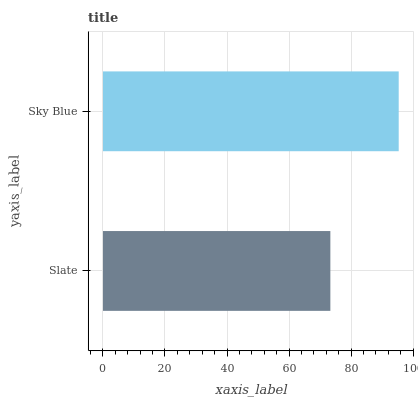Is Slate the minimum?
Answer yes or no. Yes. Is Sky Blue the maximum?
Answer yes or no. Yes. Is Sky Blue the minimum?
Answer yes or no. No. Is Sky Blue greater than Slate?
Answer yes or no. Yes. Is Slate less than Sky Blue?
Answer yes or no. Yes. Is Slate greater than Sky Blue?
Answer yes or no. No. Is Sky Blue less than Slate?
Answer yes or no. No. Is Sky Blue the high median?
Answer yes or no. Yes. Is Slate the low median?
Answer yes or no. Yes. Is Slate the high median?
Answer yes or no. No. Is Sky Blue the low median?
Answer yes or no. No. 